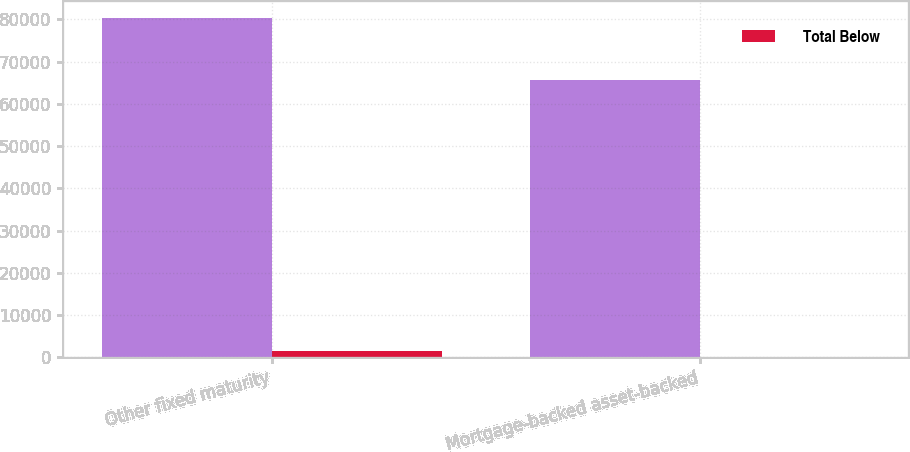<chart> <loc_0><loc_0><loc_500><loc_500><stacked_bar_chart><ecel><fcel>Other fixed maturity<fcel>Mortgage-backed asset-backed<nl><fcel>nan<fcel>80257<fcel>65767<nl><fcel>Total Below<fcel>1432<fcel>84<nl></chart> 